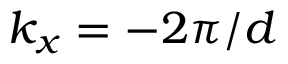<formula> <loc_0><loc_0><loc_500><loc_500>k _ { x } = - 2 \pi / d</formula> 